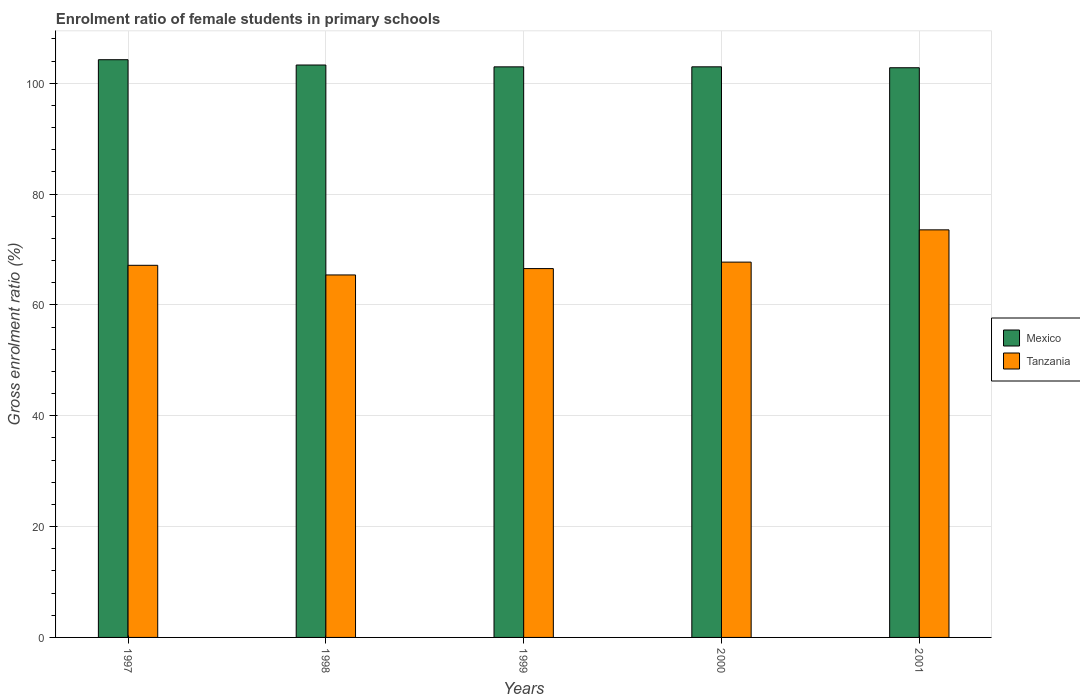How many different coloured bars are there?
Offer a very short reply. 2. Are the number of bars per tick equal to the number of legend labels?
Provide a short and direct response. Yes. How many bars are there on the 5th tick from the right?
Give a very brief answer. 2. In how many cases, is the number of bars for a given year not equal to the number of legend labels?
Your response must be concise. 0. What is the enrolment ratio of female students in primary schools in Tanzania in 2000?
Give a very brief answer. 67.73. Across all years, what is the maximum enrolment ratio of female students in primary schools in Mexico?
Offer a very short reply. 104.25. Across all years, what is the minimum enrolment ratio of female students in primary schools in Tanzania?
Make the answer very short. 65.41. What is the total enrolment ratio of female students in primary schools in Tanzania in the graph?
Ensure brevity in your answer.  340.4. What is the difference between the enrolment ratio of female students in primary schools in Tanzania in 1997 and that in 1999?
Your answer should be compact. 0.59. What is the difference between the enrolment ratio of female students in primary schools in Mexico in 1998 and the enrolment ratio of female students in primary schools in Tanzania in 2001?
Your answer should be very brief. 29.75. What is the average enrolment ratio of female students in primary schools in Mexico per year?
Give a very brief answer. 103.26. In the year 1997, what is the difference between the enrolment ratio of female students in primary schools in Tanzania and enrolment ratio of female students in primary schools in Mexico?
Provide a short and direct response. -37.1. What is the ratio of the enrolment ratio of female students in primary schools in Mexico in 1998 to that in 2001?
Your answer should be very brief. 1. Is the enrolment ratio of female students in primary schools in Tanzania in 1998 less than that in 2000?
Offer a terse response. Yes. Is the difference between the enrolment ratio of female students in primary schools in Tanzania in 1999 and 2000 greater than the difference between the enrolment ratio of female students in primary schools in Mexico in 1999 and 2000?
Offer a terse response. No. What is the difference between the highest and the second highest enrolment ratio of female students in primary schools in Mexico?
Provide a short and direct response. 0.96. What is the difference between the highest and the lowest enrolment ratio of female students in primary schools in Tanzania?
Your answer should be very brief. 8.14. What does the 2nd bar from the left in 2001 represents?
Offer a terse response. Tanzania. What does the 1st bar from the right in 1997 represents?
Your answer should be very brief. Tanzania. Are all the bars in the graph horizontal?
Your answer should be very brief. No. What is the difference between two consecutive major ticks on the Y-axis?
Provide a succinct answer. 20. Does the graph contain grids?
Your answer should be compact. Yes. How many legend labels are there?
Offer a very short reply. 2. What is the title of the graph?
Ensure brevity in your answer.  Enrolment ratio of female students in primary schools. What is the label or title of the Y-axis?
Your answer should be very brief. Gross enrolment ratio (%). What is the Gross enrolment ratio (%) in Mexico in 1997?
Your response must be concise. 104.25. What is the Gross enrolment ratio (%) in Tanzania in 1997?
Give a very brief answer. 67.15. What is the Gross enrolment ratio (%) in Mexico in 1998?
Ensure brevity in your answer.  103.3. What is the Gross enrolment ratio (%) of Tanzania in 1998?
Provide a succinct answer. 65.41. What is the Gross enrolment ratio (%) of Mexico in 1999?
Provide a succinct answer. 102.96. What is the Gross enrolment ratio (%) of Tanzania in 1999?
Make the answer very short. 66.56. What is the Gross enrolment ratio (%) of Mexico in 2000?
Offer a very short reply. 102.97. What is the Gross enrolment ratio (%) in Tanzania in 2000?
Offer a very short reply. 67.73. What is the Gross enrolment ratio (%) of Mexico in 2001?
Ensure brevity in your answer.  102.8. What is the Gross enrolment ratio (%) in Tanzania in 2001?
Provide a succinct answer. 73.55. Across all years, what is the maximum Gross enrolment ratio (%) of Mexico?
Your answer should be compact. 104.25. Across all years, what is the maximum Gross enrolment ratio (%) in Tanzania?
Offer a very short reply. 73.55. Across all years, what is the minimum Gross enrolment ratio (%) in Mexico?
Keep it short and to the point. 102.8. Across all years, what is the minimum Gross enrolment ratio (%) in Tanzania?
Provide a short and direct response. 65.41. What is the total Gross enrolment ratio (%) of Mexico in the graph?
Your answer should be very brief. 516.29. What is the total Gross enrolment ratio (%) of Tanzania in the graph?
Offer a terse response. 340.4. What is the difference between the Gross enrolment ratio (%) of Mexico in 1997 and that in 1998?
Give a very brief answer. 0.96. What is the difference between the Gross enrolment ratio (%) in Tanzania in 1997 and that in 1998?
Offer a terse response. 1.74. What is the difference between the Gross enrolment ratio (%) in Mexico in 1997 and that in 1999?
Your response must be concise. 1.29. What is the difference between the Gross enrolment ratio (%) of Tanzania in 1997 and that in 1999?
Your answer should be compact. 0.59. What is the difference between the Gross enrolment ratio (%) of Mexico in 1997 and that in 2000?
Your answer should be very brief. 1.28. What is the difference between the Gross enrolment ratio (%) of Tanzania in 1997 and that in 2000?
Make the answer very short. -0.57. What is the difference between the Gross enrolment ratio (%) in Mexico in 1997 and that in 2001?
Your response must be concise. 1.45. What is the difference between the Gross enrolment ratio (%) of Tanzania in 1997 and that in 2001?
Offer a terse response. -6.4. What is the difference between the Gross enrolment ratio (%) of Mexico in 1998 and that in 1999?
Offer a very short reply. 0.33. What is the difference between the Gross enrolment ratio (%) in Tanzania in 1998 and that in 1999?
Give a very brief answer. -1.15. What is the difference between the Gross enrolment ratio (%) in Mexico in 1998 and that in 2000?
Keep it short and to the point. 0.33. What is the difference between the Gross enrolment ratio (%) of Tanzania in 1998 and that in 2000?
Give a very brief answer. -2.31. What is the difference between the Gross enrolment ratio (%) of Mexico in 1998 and that in 2001?
Ensure brevity in your answer.  0.49. What is the difference between the Gross enrolment ratio (%) in Tanzania in 1998 and that in 2001?
Keep it short and to the point. -8.14. What is the difference between the Gross enrolment ratio (%) of Mexico in 1999 and that in 2000?
Offer a very short reply. -0. What is the difference between the Gross enrolment ratio (%) of Tanzania in 1999 and that in 2000?
Your answer should be very brief. -1.17. What is the difference between the Gross enrolment ratio (%) of Mexico in 1999 and that in 2001?
Give a very brief answer. 0.16. What is the difference between the Gross enrolment ratio (%) of Tanzania in 1999 and that in 2001?
Ensure brevity in your answer.  -6.99. What is the difference between the Gross enrolment ratio (%) in Mexico in 2000 and that in 2001?
Ensure brevity in your answer.  0.17. What is the difference between the Gross enrolment ratio (%) of Tanzania in 2000 and that in 2001?
Offer a terse response. -5.82. What is the difference between the Gross enrolment ratio (%) in Mexico in 1997 and the Gross enrolment ratio (%) in Tanzania in 1998?
Offer a terse response. 38.84. What is the difference between the Gross enrolment ratio (%) in Mexico in 1997 and the Gross enrolment ratio (%) in Tanzania in 1999?
Offer a terse response. 37.69. What is the difference between the Gross enrolment ratio (%) of Mexico in 1997 and the Gross enrolment ratio (%) of Tanzania in 2000?
Provide a short and direct response. 36.53. What is the difference between the Gross enrolment ratio (%) in Mexico in 1997 and the Gross enrolment ratio (%) in Tanzania in 2001?
Offer a terse response. 30.7. What is the difference between the Gross enrolment ratio (%) of Mexico in 1998 and the Gross enrolment ratio (%) of Tanzania in 1999?
Keep it short and to the point. 36.74. What is the difference between the Gross enrolment ratio (%) in Mexico in 1998 and the Gross enrolment ratio (%) in Tanzania in 2000?
Keep it short and to the point. 35.57. What is the difference between the Gross enrolment ratio (%) in Mexico in 1998 and the Gross enrolment ratio (%) in Tanzania in 2001?
Make the answer very short. 29.75. What is the difference between the Gross enrolment ratio (%) of Mexico in 1999 and the Gross enrolment ratio (%) of Tanzania in 2000?
Your answer should be compact. 35.24. What is the difference between the Gross enrolment ratio (%) of Mexico in 1999 and the Gross enrolment ratio (%) of Tanzania in 2001?
Keep it short and to the point. 29.41. What is the difference between the Gross enrolment ratio (%) in Mexico in 2000 and the Gross enrolment ratio (%) in Tanzania in 2001?
Your answer should be compact. 29.42. What is the average Gross enrolment ratio (%) in Mexico per year?
Your answer should be compact. 103.26. What is the average Gross enrolment ratio (%) of Tanzania per year?
Provide a succinct answer. 68.08. In the year 1997, what is the difference between the Gross enrolment ratio (%) of Mexico and Gross enrolment ratio (%) of Tanzania?
Give a very brief answer. 37.1. In the year 1998, what is the difference between the Gross enrolment ratio (%) in Mexico and Gross enrolment ratio (%) in Tanzania?
Ensure brevity in your answer.  37.89. In the year 1999, what is the difference between the Gross enrolment ratio (%) in Mexico and Gross enrolment ratio (%) in Tanzania?
Your response must be concise. 36.4. In the year 2000, what is the difference between the Gross enrolment ratio (%) in Mexico and Gross enrolment ratio (%) in Tanzania?
Provide a short and direct response. 35.24. In the year 2001, what is the difference between the Gross enrolment ratio (%) in Mexico and Gross enrolment ratio (%) in Tanzania?
Your response must be concise. 29.25. What is the ratio of the Gross enrolment ratio (%) of Mexico in 1997 to that in 1998?
Offer a very short reply. 1.01. What is the ratio of the Gross enrolment ratio (%) in Tanzania in 1997 to that in 1998?
Make the answer very short. 1.03. What is the ratio of the Gross enrolment ratio (%) of Mexico in 1997 to that in 1999?
Keep it short and to the point. 1.01. What is the ratio of the Gross enrolment ratio (%) in Tanzania in 1997 to that in 1999?
Give a very brief answer. 1.01. What is the ratio of the Gross enrolment ratio (%) of Mexico in 1997 to that in 2000?
Your response must be concise. 1.01. What is the ratio of the Gross enrolment ratio (%) of Mexico in 1997 to that in 2001?
Make the answer very short. 1.01. What is the ratio of the Gross enrolment ratio (%) of Tanzania in 1998 to that in 1999?
Your answer should be very brief. 0.98. What is the ratio of the Gross enrolment ratio (%) in Tanzania in 1998 to that in 2000?
Provide a succinct answer. 0.97. What is the ratio of the Gross enrolment ratio (%) in Mexico in 1998 to that in 2001?
Your response must be concise. 1. What is the ratio of the Gross enrolment ratio (%) of Tanzania in 1998 to that in 2001?
Keep it short and to the point. 0.89. What is the ratio of the Gross enrolment ratio (%) in Mexico in 1999 to that in 2000?
Your response must be concise. 1. What is the ratio of the Gross enrolment ratio (%) in Tanzania in 1999 to that in 2000?
Make the answer very short. 0.98. What is the ratio of the Gross enrolment ratio (%) in Mexico in 1999 to that in 2001?
Your answer should be compact. 1. What is the ratio of the Gross enrolment ratio (%) of Tanzania in 1999 to that in 2001?
Ensure brevity in your answer.  0.91. What is the ratio of the Gross enrolment ratio (%) in Mexico in 2000 to that in 2001?
Offer a very short reply. 1. What is the ratio of the Gross enrolment ratio (%) of Tanzania in 2000 to that in 2001?
Give a very brief answer. 0.92. What is the difference between the highest and the second highest Gross enrolment ratio (%) of Mexico?
Make the answer very short. 0.96. What is the difference between the highest and the second highest Gross enrolment ratio (%) of Tanzania?
Provide a short and direct response. 5.82. What is the difference between the highest and the lowest Gross enrolment ratio (%) in Mexico?
Offer a terse response. 1.45. What is the difference between the highest and the lowest Gross enrolment ratio (%) of Tanzania?
Your answer should be compact. 8.14. 